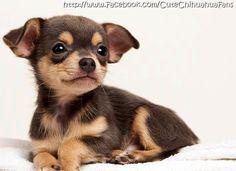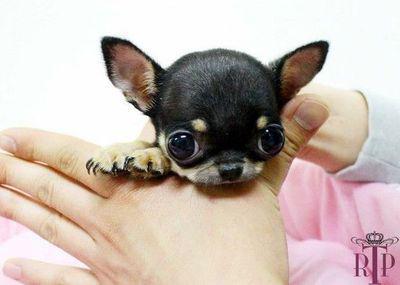The first image is the image on the left, the second image is the image on the right. Given the left and right images, does the statement "An image shows a teacup puppy held by a human hand." hold true? Answer yes or no. Yes. The first image is the image on the left, the second image is the image on the right. For the images shown, is this caption "Someone is holding the dog on the right." true? Answer yes or no. Yes. 